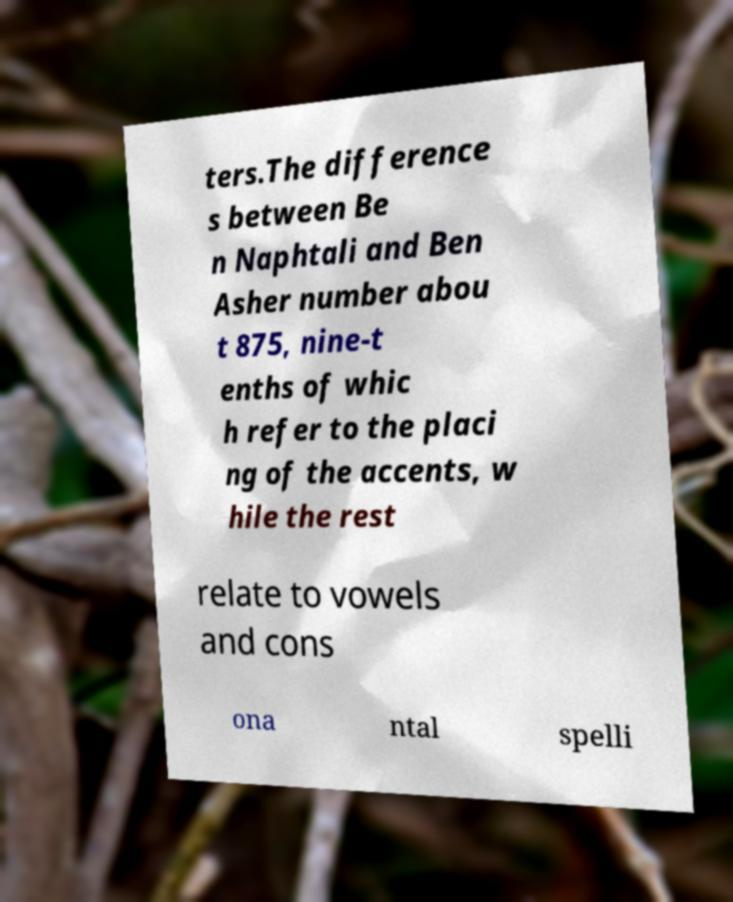Please read and relay the text visible in this image. What does it say? ters.The difference s between Be n Naphtali and Ben Asher number abou t 875, nine-t enths of whic h refer to the placi ng of the accents, w hile the rest relate to vowels and cons ona ntal spelli 